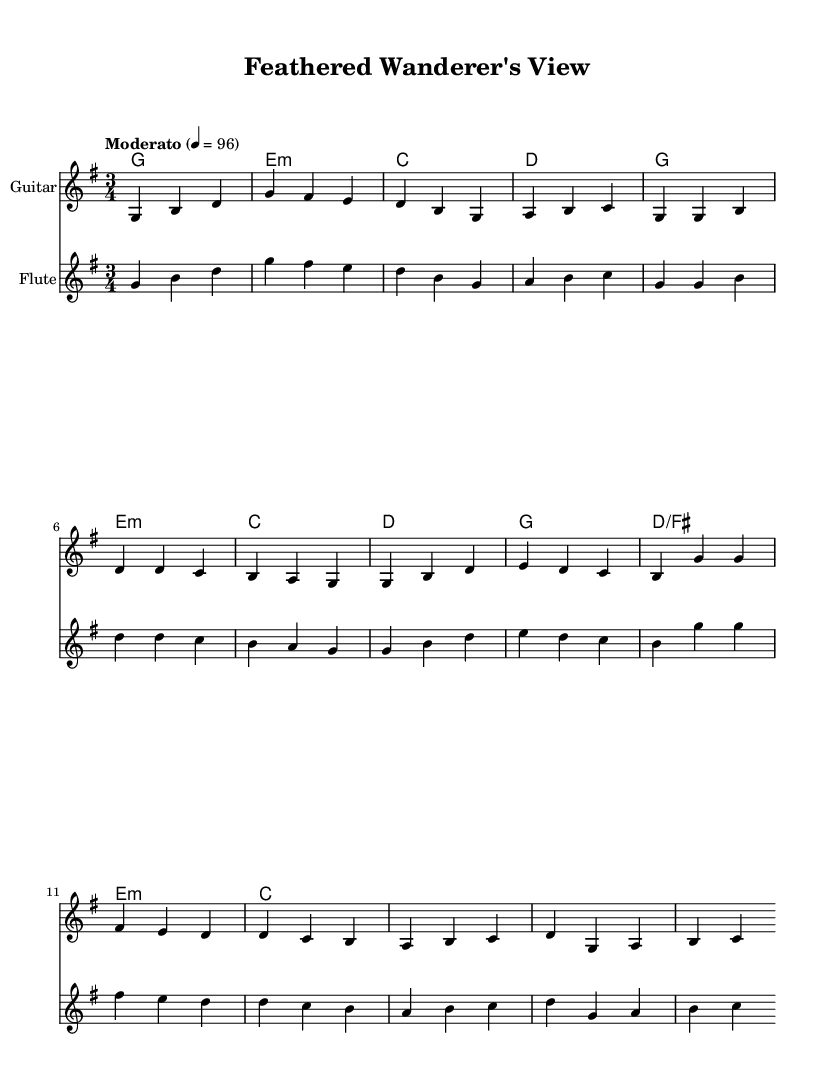What is the key signature of this music? The key signature shows one sharp (F#), indicating that the piece is in G major.
Answer: G major What is the time signature of this music? The time signature is written as 3/4, meaning there are three beats in each measure and the quarter note receives one beat.
Answer: 3/4 What is the tempo marking for this piece? The tempo marking "Moderato" indicates a moderate pace, and it is set at 96 beats per minute.
Answer: Moderato 4 = 96 How many measures does the piece consist of in the provided snippet? The snippet includes measures from the Introduction, Verse 1, and Chorus, totaling 12 measures visible in the score.
Answer: 12 measures Which instrument plays the introduction along with the flute in the piece? The guitar plays the introduction alongside the flute as indicated in the score.
Answer: Guitar What is the first note of the flute's melody? The first note of the flute's melody is G, which is shown as the first note in the introduction.
Answer: G Identify a chord used in the chorus section. The chord used in the chorus section includes G major, as indicated in the chord progressions provided.
Answer: G major 